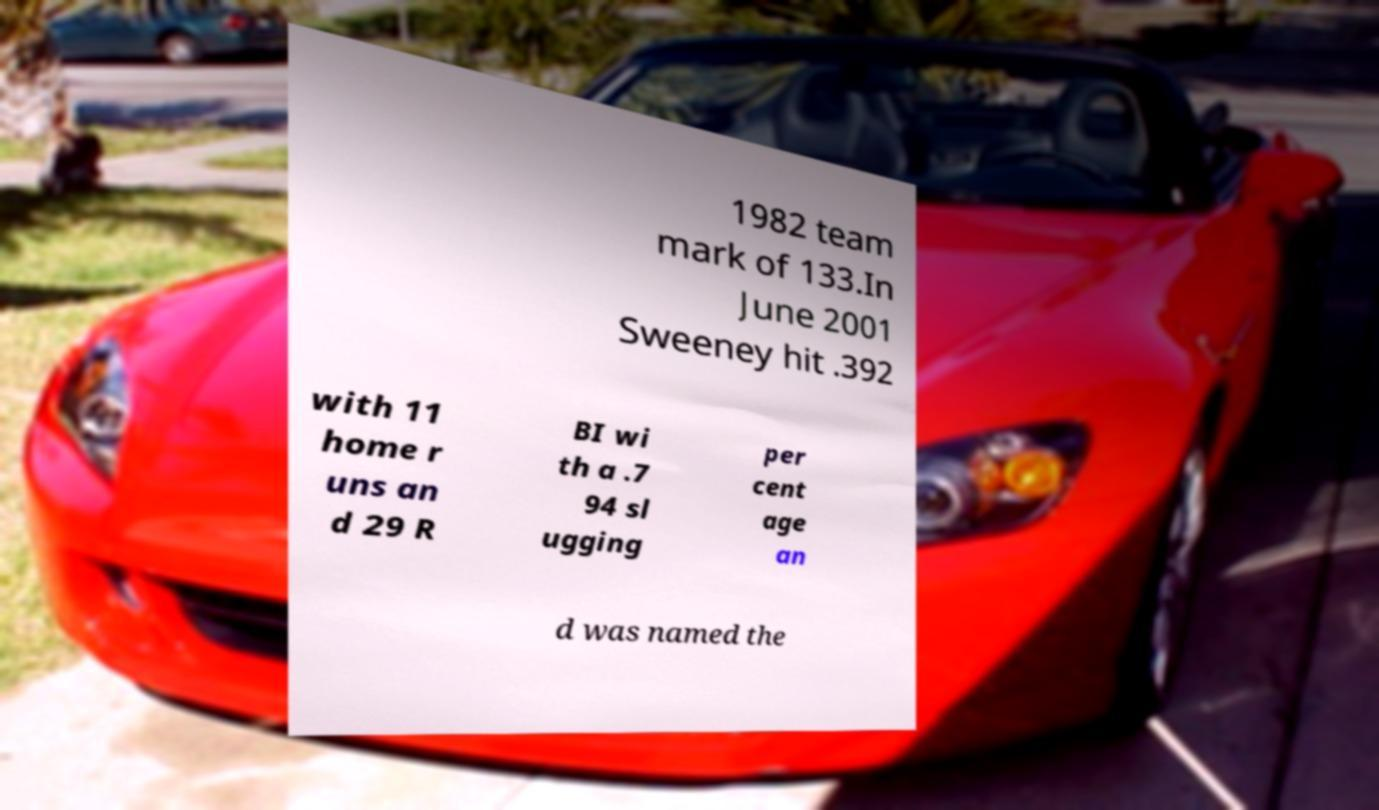Please read and relay the text visible in this image. What does it say? 1982 team mark of 133.In June 2001 Sweeney hit .392 with 11 home r uns an d 29 R BI wi th a .7 94 sl ugging per cent age an d was named the 